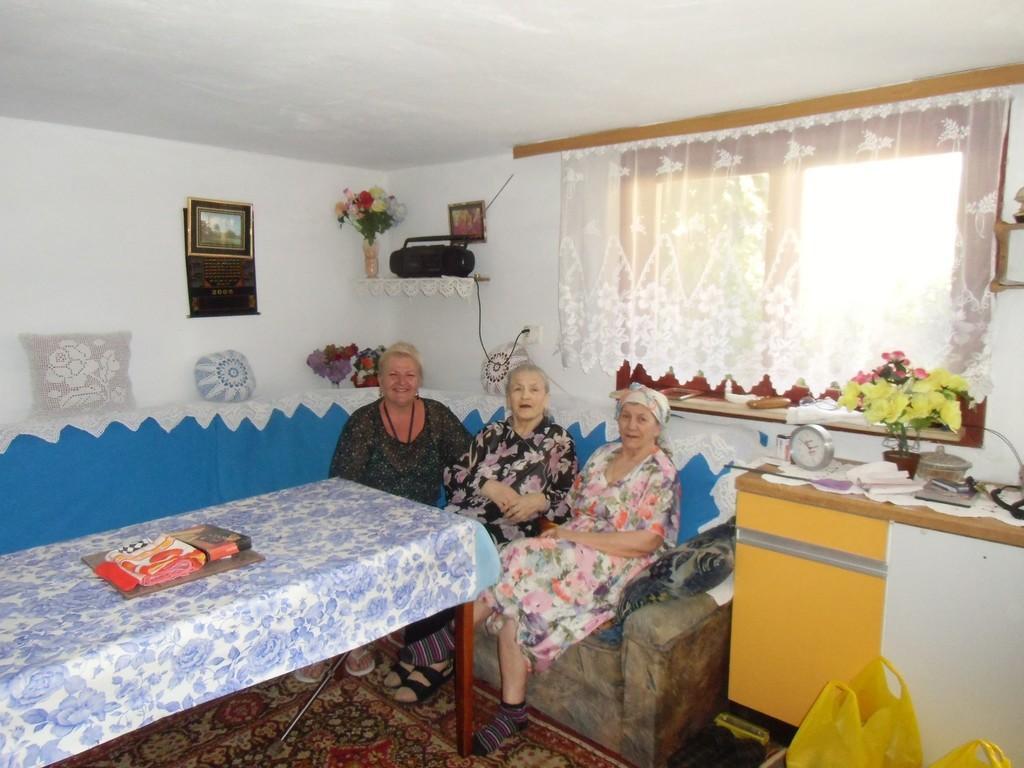Describe this image in one or two sentences. In the picture we can see three women sitting on sofa near a table, the table is covered with tablecloth it is designed with flowers on it we can see a cloth, in the background we can see a wall, window with curtain and just beside it there is a table on the table we can see flower vase with flowers, a clock, papers, and some bowl and we can also see a tape recorder, photo frame and a switch. 